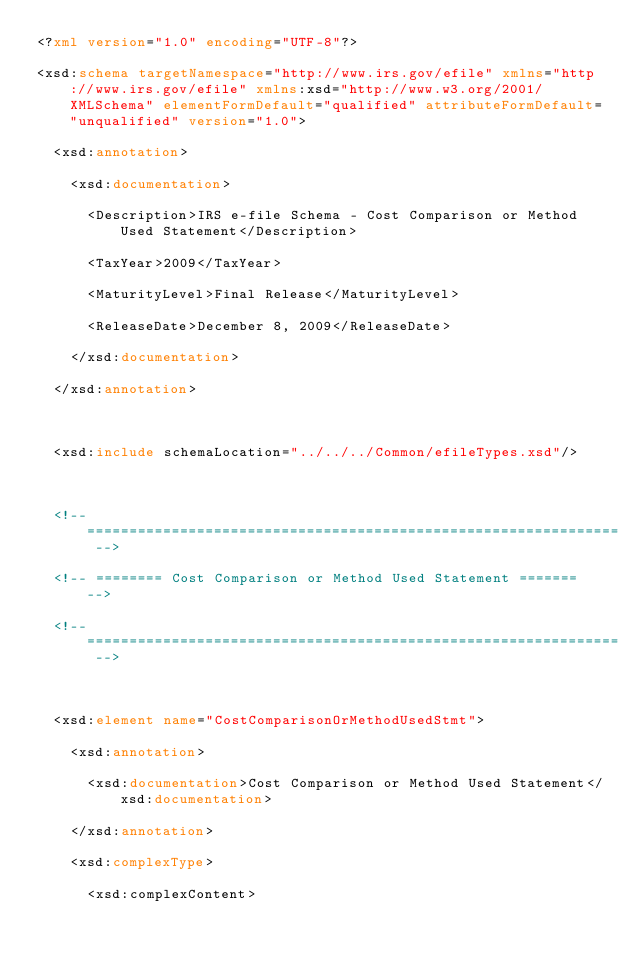Convert code to text. <code><loc_0><loc_0><loc_500><loc_500><_XML_><?xml version="1.0" encoding="UTF-8"?>
<xsd:schema targetNamespace="http://www.irs.gov/efile" xmlns="http://www.irs.gov/efile" xmlns:xsd="http://www.w3.org/2001/XMLSchema" elementFormDefault="qualified" attributeFormDefault="unqualified" version="1.0">
	<xsd:annotation>
		<xsd:documentation>
			<Description>IRS e-file Schema - Cost Comparison or Method Used Statement</Description>
			<TaxYear>2009</TaxYear>
			<MaturityLevel>Final Release</MaturityLevel>
			<ReleaseDate>December 8, 2009</ReleaseDate>
		</xsd:documentation>
	</xsd:annotation>

	<xsd:include schemaLocation="../../../Common/efileTypes.xsd"/>

	<!-- =============================================================== -->
	<!-- ======== Cost Comparison or Method Used Statement ======= -->
	<!-- =============================================================== -->

	<xsd:element name="CostComparisonOrMethodUsedStmt">
		<xsd:annotation>
			<xsd:documentation>Cost Comparison or Method Used Statement</xsd:documentation>
		</xsd:annotation>
		<xsd:complexType>
			<xsd:complexContent></code> 